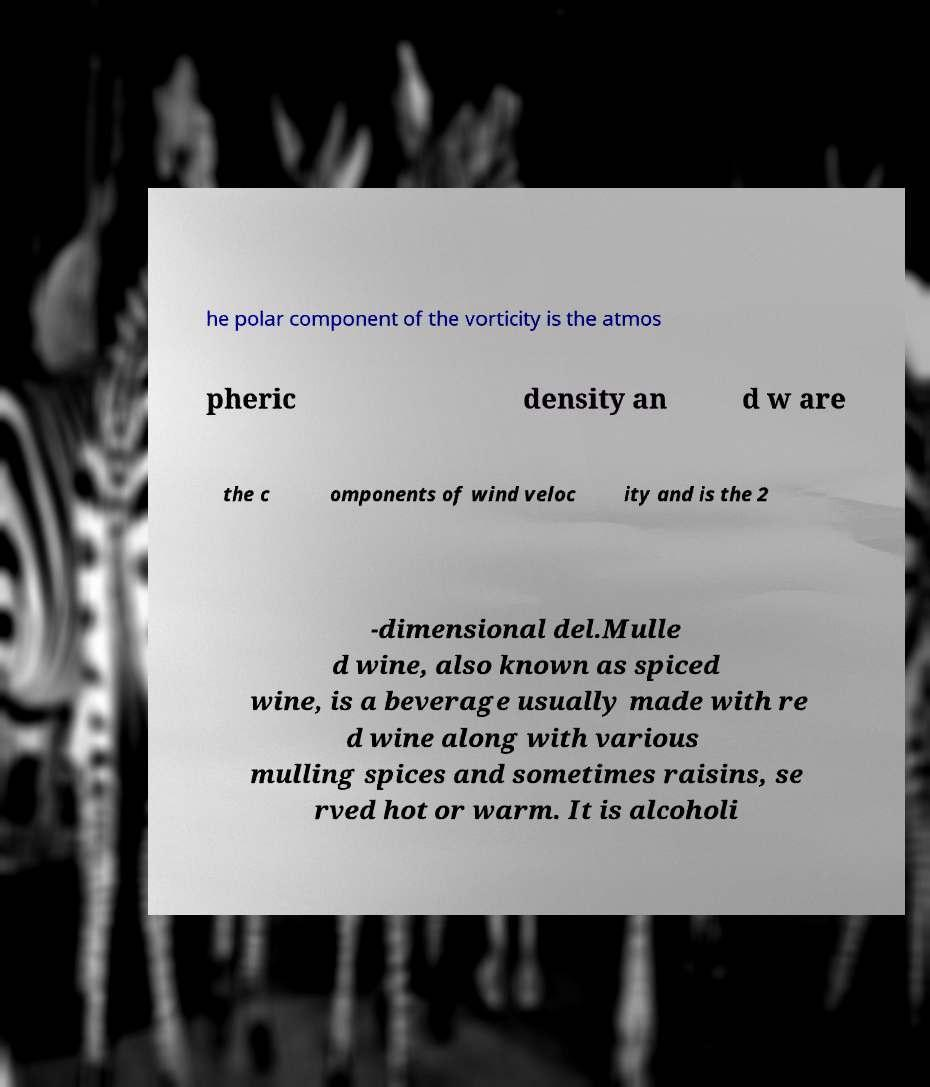Can you read and provide the text displayed in the image?This photo seems to have some interesting text. Can you extract and type it out for me? he polar component of the vorticity is the atmos pheric density an d w are the c omponents of wind veloc ity and is the 2 -dimensional del.Mulle d wine, also known as spiced wine, is a beverage usually made with re d wine along with various mulling spices and sometimes raisins, se rved hot or warm. It is alcoholi 